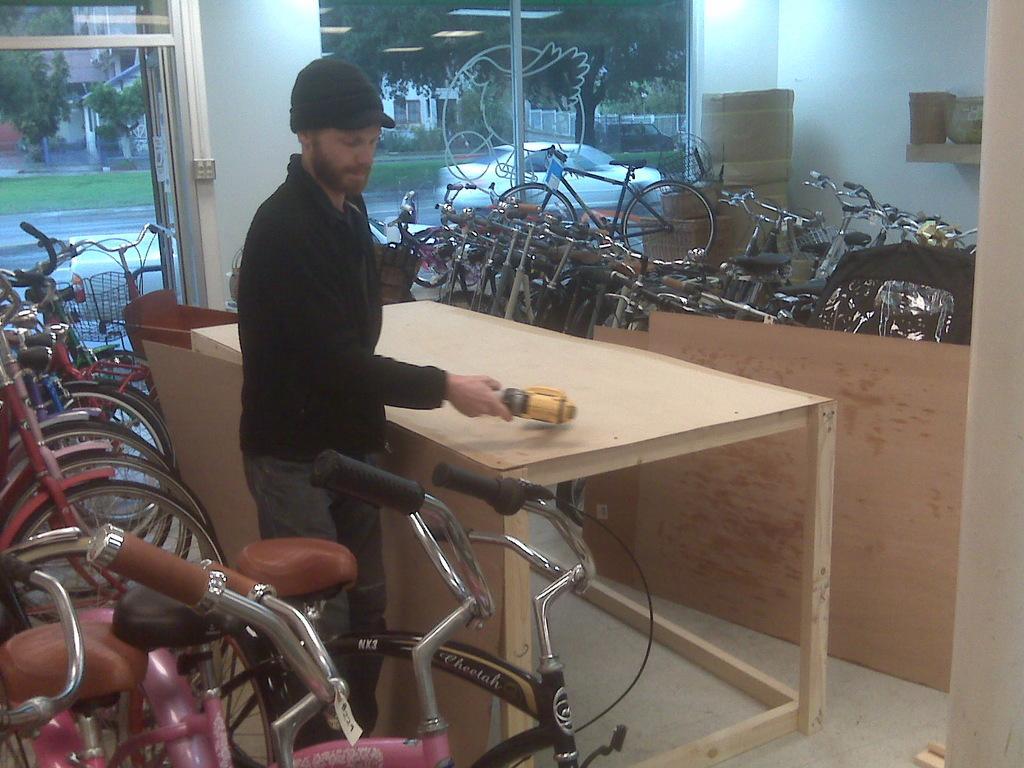How would you summarize this image in a sentence or two? in the picture we can see the bicycle shop,here we can also see the person holding something on his hand,here we can see the table near to the bicycle,here we can also see the trees and building through the window which is near to the wall a beautiful scenery. 